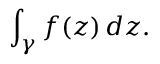Convert formula to latex. <formula><loc_0><loc_0><loc_500><loc_500>\int _ { \gamma } f ( z ) \, d z .</formula> 